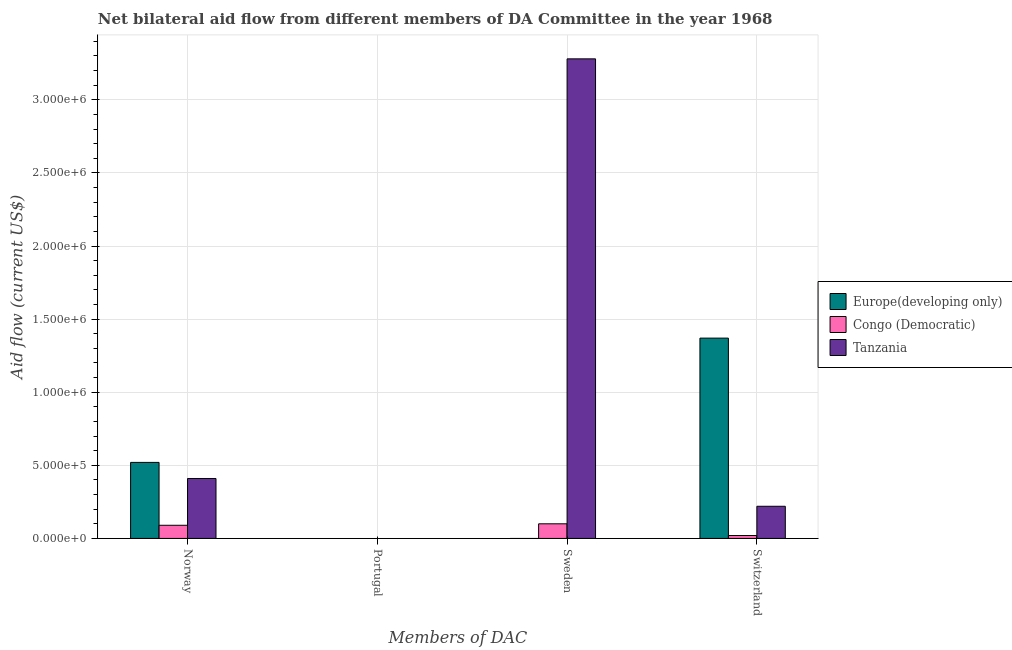How many different coloured bars are there?
Offer a terse response. 3. How many bars are there on the 3rd tick from the right?
Keep it short and to the point. 0. What is the label of the 1st group of bars from the left?
Offer a terse response. Norway. What is the amount of aid given by sweden in Europe(developing only)?
Provide a succinct answer. 0. Across all countries, what is the maximum amount of aid given by norway?
Your answer should be compact. 5.20e+05. Across all countries, what is the minimum amount of aid given by sweden?
Provide a short and direct response. 0. In which country was the amount of aid given by sweden maximum?
Give a very brief answer. Tanzania. What is the total amount of aid given by portugal in the graph?
Offer a terse response. 0. What is the difference between the amount of aid given by norway in Congo (Democratic) and that in Europe(developing only)?
Your response must be concise. -4.30e+05. What is the average amount of aid given by portugal per country?
Make the answer very short. 0. What is the difference between the amount of aid given by norway and amount of aid given by switzerland in Europe(developing only)?
Make the answer very short. -8.50e+05. In how many countries, is the amount of aid given by portugal greater than 600000 US$?
Your answer should be compact. 0. What is the ratio of the amount of aid given by norway in Tanzania to that in Congo (Democratic)?
Ensure brevity in your answer.  4.56. What is the difference between the highest and the lowest amount of aid given by sweden?
Ensure brevity in your answer.  3.28e+06. How many bars are there?
Give a very brief answer. 11. Are all the bars in the graph horizontal?
Offer a terse response. No. How many countries are there in the graph?
Provide a short and direct response. 3. Are the values on the major ticks of Y-axis written in scientific E-notation?
Keep it short and to the point. Yes. Does the graph contain grids?
Your answer should be compact. Yes. How many legend labels are there?
Make the answer very short. 3. What is the title of the graph?
Ensure brevity in your answer.  Net bilateral aid flow from different members of DA Committee in the year 1968. Does "American Samoa" appear as one of the legend labels in the graph?
Keep it short and to the point. No. What is the label or title of the X-axis?
Offer a terse response. Members of DAC. What is the Aid flow (current US$) in Europe(developing only) in Norway?
Make the answer very short. 5.20e+05. What is the Aid flow (current US$) in Congo (Democratic) in Norway?
Your response must be concise. 9.00e+04. What is the Aid flow (current US$) in Europe(developing only) in Portugal?
Provide a short and direct response. Nan. What is the Aid flow (current US$) in Congo (Democratic) in Portugal?
Make the answer very short. Nan. What is the Aid flow (current US$) in Tanzania in Portugal?
Your response must be concise. Nan. What is the Aid flow (current US$) of Europe(developing only) in Sweden?
Offer a very short reply. 0. What is the Aid flow (current US$) of Tanzania in Sweden?
Provide a succinct answer. 3.28e+06. What is the Aid flow (current US$) of Europe(developing only) in Switzerland?
Your answer should be very brief. 1.37e+06. What is the Aid flow (current US$) of Congo (Democratic) in Switzerland?
Ensure brevity in your answer.  2.00e+04. Across all Members of DAC, what is the maximum Aid flow (current US$) of Europe(developing only)?
Ensure brevity in your answer.  1.37e+06. Across all Members of DAC, what is the maximum Aid flow (current US$) of Tanzania?
Your response must be concise. 3.28e+06. Across all Members of DAC, what is the minimum Aid flow (current US$) in Congo (Democratic)?
Keep it short and to the point. 2.00e+04. What is the total Aid flow (current US$) of Europe(developing only) in the graph?
Offer a terse response. 1.89e+06. What is the total Aid flow (current US$) of Tanzania in the graph?
Ensure brevity in your answer.  3.91e+06. What is the difference between the Aid flow (current US$) in Europe(developing only) in Norway and that in Portugal?
Your answer should be compact. Nan. What is the difference between the Aid flow (current US$) in Congo (Democratic) in Norway and that in Portugal?
Provide a succinct answer. Nan. What is the difference between the Aid flow (current US$) in Tanzania in Norway and that in Portugal?
Give a very brief answer. Nan. What is the difference between the Aid flow (current US$) of Congo (Democratic) in Norway and that in Sweden?
Your answer should be very brief. -10000. What is the difference between the Aid flow (current US$) in Tanzania in Norway and that in Sweden?
Keep it short and to the point. -2.87e+06. What is the difference between the Aid flow (current US$) in Europe(developing only) in Norway and that in Switzerland?
Make the answer very short. -8.50e+05. What is the difference between the Aid flow (current US$) of Congo (Democratic) in Norway and that in Switzerland?
Provide a succinct answer. 7.00e+04. What is the difference between the Aid flow (current US$) of Tanzania in Norway and that in Switzerland?
Your answer should be compact. 1.90e+05. What is the difference between the Aid flow (current US$) in Congo (Democratic) in Portugal and that in Sweden?
Keep it short and to the point. Nan. What is the difference between the Aid flow (current US$) of Tanzania in Portugal and that in Sweden?
Provide a succinct answer. Nan. What is the difference between the Aid flow (current US$) in Europe(developing only) in Portugal and that in Switzerland?
Keep it short and to the point. Nan. What is the difference between the Aid flow (current US$) of Congo (Democratic) in Portugal and that in Switzerland?
Offer a very short reply. Nan. What is the difference between the Aid flow (current US$) of Tanzania in Portugal and that in Switzerland?
Keep it short and to the point. Nan. What is the difference between the Aid flow (current US$) in Congo (Democratic) in Sweden and that in Switzerland?
Make the answer very short. 8.00e+04. What is the difference between the Aid flow (current US$) of Tanzania in Sweden and that in Switzerland?
Offer a very short reply. 3.06e+06. What is the difference between the Aid flow (current US$) in Europe(developing only) in Norway and the Aid flow (current US$) in Congo (Democratic) in Portugal?
Your response must be concise. Nan. What is the difference between the Aid flow (current US$) of Europe(developing only) in Norway and the Aid flow (current US$) of Tanzania in Portugal?
Offer a very short reply. Nan. What is the difference between the Aid flow (current US$) of Congo (Democratic) in Norway and the Aid flow (current US$) of Tanzania in Portugal?
Provide a succinct answer. Nan. What is the difference between the Aid flow (current US$) in Europe(developing only) in Norway and the Aid flow (current US$) in Congo (Democratic) in Sweden?
Your response must be concise. 4.20e+05. What is the difference between the Aid flow (current US$) of Europe(developing only) in Norway and the Aid flow (current US$) of Tanzania in Sweden?
Ensure brevity in your answer.  -2.76e+06. What is the difference between the Aid flow (current US$) in Congo (Democratic) in Norway and the Aid flow (current US$) in Tanzania in Sweden?
Your response must be concise. -3.19e+06. What is the difference between the Aid flow (current US$) of Europe(developing only) in Norway and the Aid flow (current US$) of Tanzania in Switzerland?
Keep it short and to the point. 3.00e+05. What is the difference between the Aid flow (current US$) in Europe(developing only) in Portugal and the Aid flow (current US$) in Congo (Democratic) in Sweden?
Your response must be concise. Nan. What is the difference between the Aid flow (current US$) of Europe(developing only) in Portugal and the Aid flow (current US$) of Tanzania in Sweden?
Ensure brevity in your answer.  Nan. What is the difference between the Aid flow (current US$) of Congo (Democratic) in Portugal and the Aid flow (current US$) of Tanzania in Sweden?
Your response must be concise. Nan. What is the difference between the Aid flow (current US$) in Europe(developing only) in Portugal and the Aid flow (current US$) in Congo (Democratic) in Switzerland?
Offer a very short reply. Nan. What is the difference between the Aid flow (current US$) in Europe(developing only) in Portugal and the Aid flow (current US$) in Tanzania in Switzerland?
Keep it short and to the point. Nan. What is the difference between the Aid flow (current US$) of Congo (Democratic) in Portugal and the Aid flow (current US$) of Tanzania in Switzerland?
Give a very brief answer. Nan. What is the difference between the Aid flow (current US$) in Congo (Democratic) in Sweden and the Aid flow (current US$) in Tanzania in Switzerland?
Provide a short and direct response. -1.20e+05. What is the average Aid flow (current US$) in Europe(developing only) per Members of DAC?
Your response must be concise. 4.72e+05. What is the average Aid flow (current US$) of Congo (Democratic) per Members of DAC?
Give a very brief answer. 5.25e+04. What is the average Aid flow (current US$) in Tanzania per Members of DAC?
Provide a short and direct response. 9.78e+05. What is the difference between the Aid flow (current US$) of Europe(developing only) and Aid flow (current US$) of Tanzania in Norway?
Ensure brevity in your answer.  1.10e+05. What is the difference between the Aid flow (current US$) of Congo (Democratic) and Aid flow (current US$) of Tanzania in Norway?
Give a very brief answer. -3.20e+05. What is the difference between the Aid flow (current US$) of Europe(developing only) and Aid flow (current US$) of Congo (Democratic) in Portugal?
Give a very brief answer. Nan. What is the difference between the Aid flow (current US$) in Europe(developing only) and Aid flow (current US$) in Tanzania in Portugal?
Your response must be concise. Nan. What is the difference between the Aid flow (current US$) of Congo (Democratic) and Aid flow (current US$) of Tanzania in Portugal?
Offer a terse response. Nan. What is the difference between the Aid flow (current US$) in Congo (Democratic) and Aid flow (current US$) in Tanzania in Sweden?
Your response must be concise. -3.18e+06. What is the difference between the Aid flow (current US$) in Europe(developing only) and Aid flow (current US$) in Congo (Democratic) in Switzerland?
Offer a very short reply. 1.35e+06. What is the difference between the Aid flow (current US$) of Europe(developing only) and Aid flow (current US$) of Tanzania in Switzerland?
Provide a short and direct response. 1.15e+06. What is the difference between the Aid flow (current US$) of Congo (Democratic) and Aid flow (current US$) of Tanzania in Switzerland?
Provide a succinct answer. -2.00e+05. What is the ratio of the Aid flow (current US$) in Europe(developing only) in Norway to that in Portugal?
Your answer should be compact. Nan. What is the ratio of the Aid flow (current US$) of Congo (Democratic) in Norway to that in Portugal?
Provide a succinct answer. Nan. What is the ratio of the Aid flow (current US$) in Tanzania in Norway to that in Portugal?
Ensure brevity in your answer.  Nan. What is the ratio of the Aid flow (current US$) in Europe(developing only) in Norway to that in Switzerland?
Offer a terse response. 0.38. What is the ratio of the Aid flow (current US$) in Tanzania in Norway to that in Switzerland?
Make the answer very short. 1.86. What is the ratio of the Aid flow (current US$) of Congo (Democratic) in Portugal to that in Sweden?
Provide a short and direct response. Nan. What is the ratio of the Aid flow (current US$) of Tanzania in Portugal to that in Sweden?
Your answer should be very brief. Nan. What is the ratio of the Aid flow (current US$) in Europe(developing only) in Portugal to that in Switzerland?
Offer a terse response. Nan. What is the ratio of the Aid flow (current US$) of Congo (Democratic) in Portugal to that in Switzerland?
Make the answer very short. Nan. What is the ratio of the Aid flow (current US$) of Tanzania in Portugal to that in Switzerland?
Offer a very short reply. Nan. What is the ratio of the Aid flow (current US$) in Tanzania in Sweden to that in Switzerland?
Offer a terse response. 14.91. What is the difference between the highest and the second highest Aid flow (current US$) in Congo (Democratic)?
Provide a short and direct response. 10000. What is the difference between the highest and the second highest Aid flow (current US$) of Tanzania?
Provide a succinct answer. 2.87e+06. What is the difference between the highest and the lowest Aid flow (current US$) of Europe(developing only)?
Your response must be concise. 1.37e+06. What is the difference between the highest and the lowest Aid flow (current US$) in Tanzania?
Offer a terse response. 3.06e+06. 